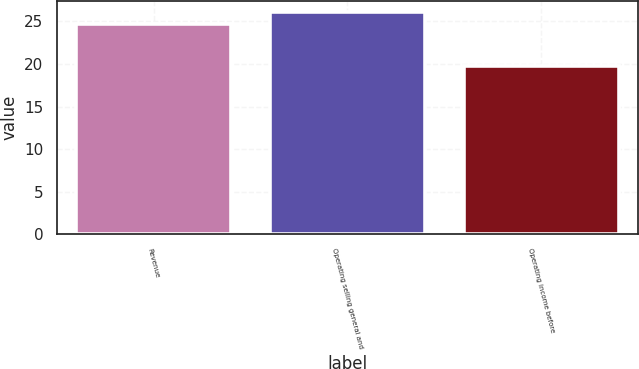<chart> <loc_0><loc_0><loc_500><loc_500><bar_chart><fcel>Revenue<fcel>Operating selling general and<fcel>Operating income before<nl><fcel>24.7<fcel>26.1<fcel>19.8<nl></chart> 